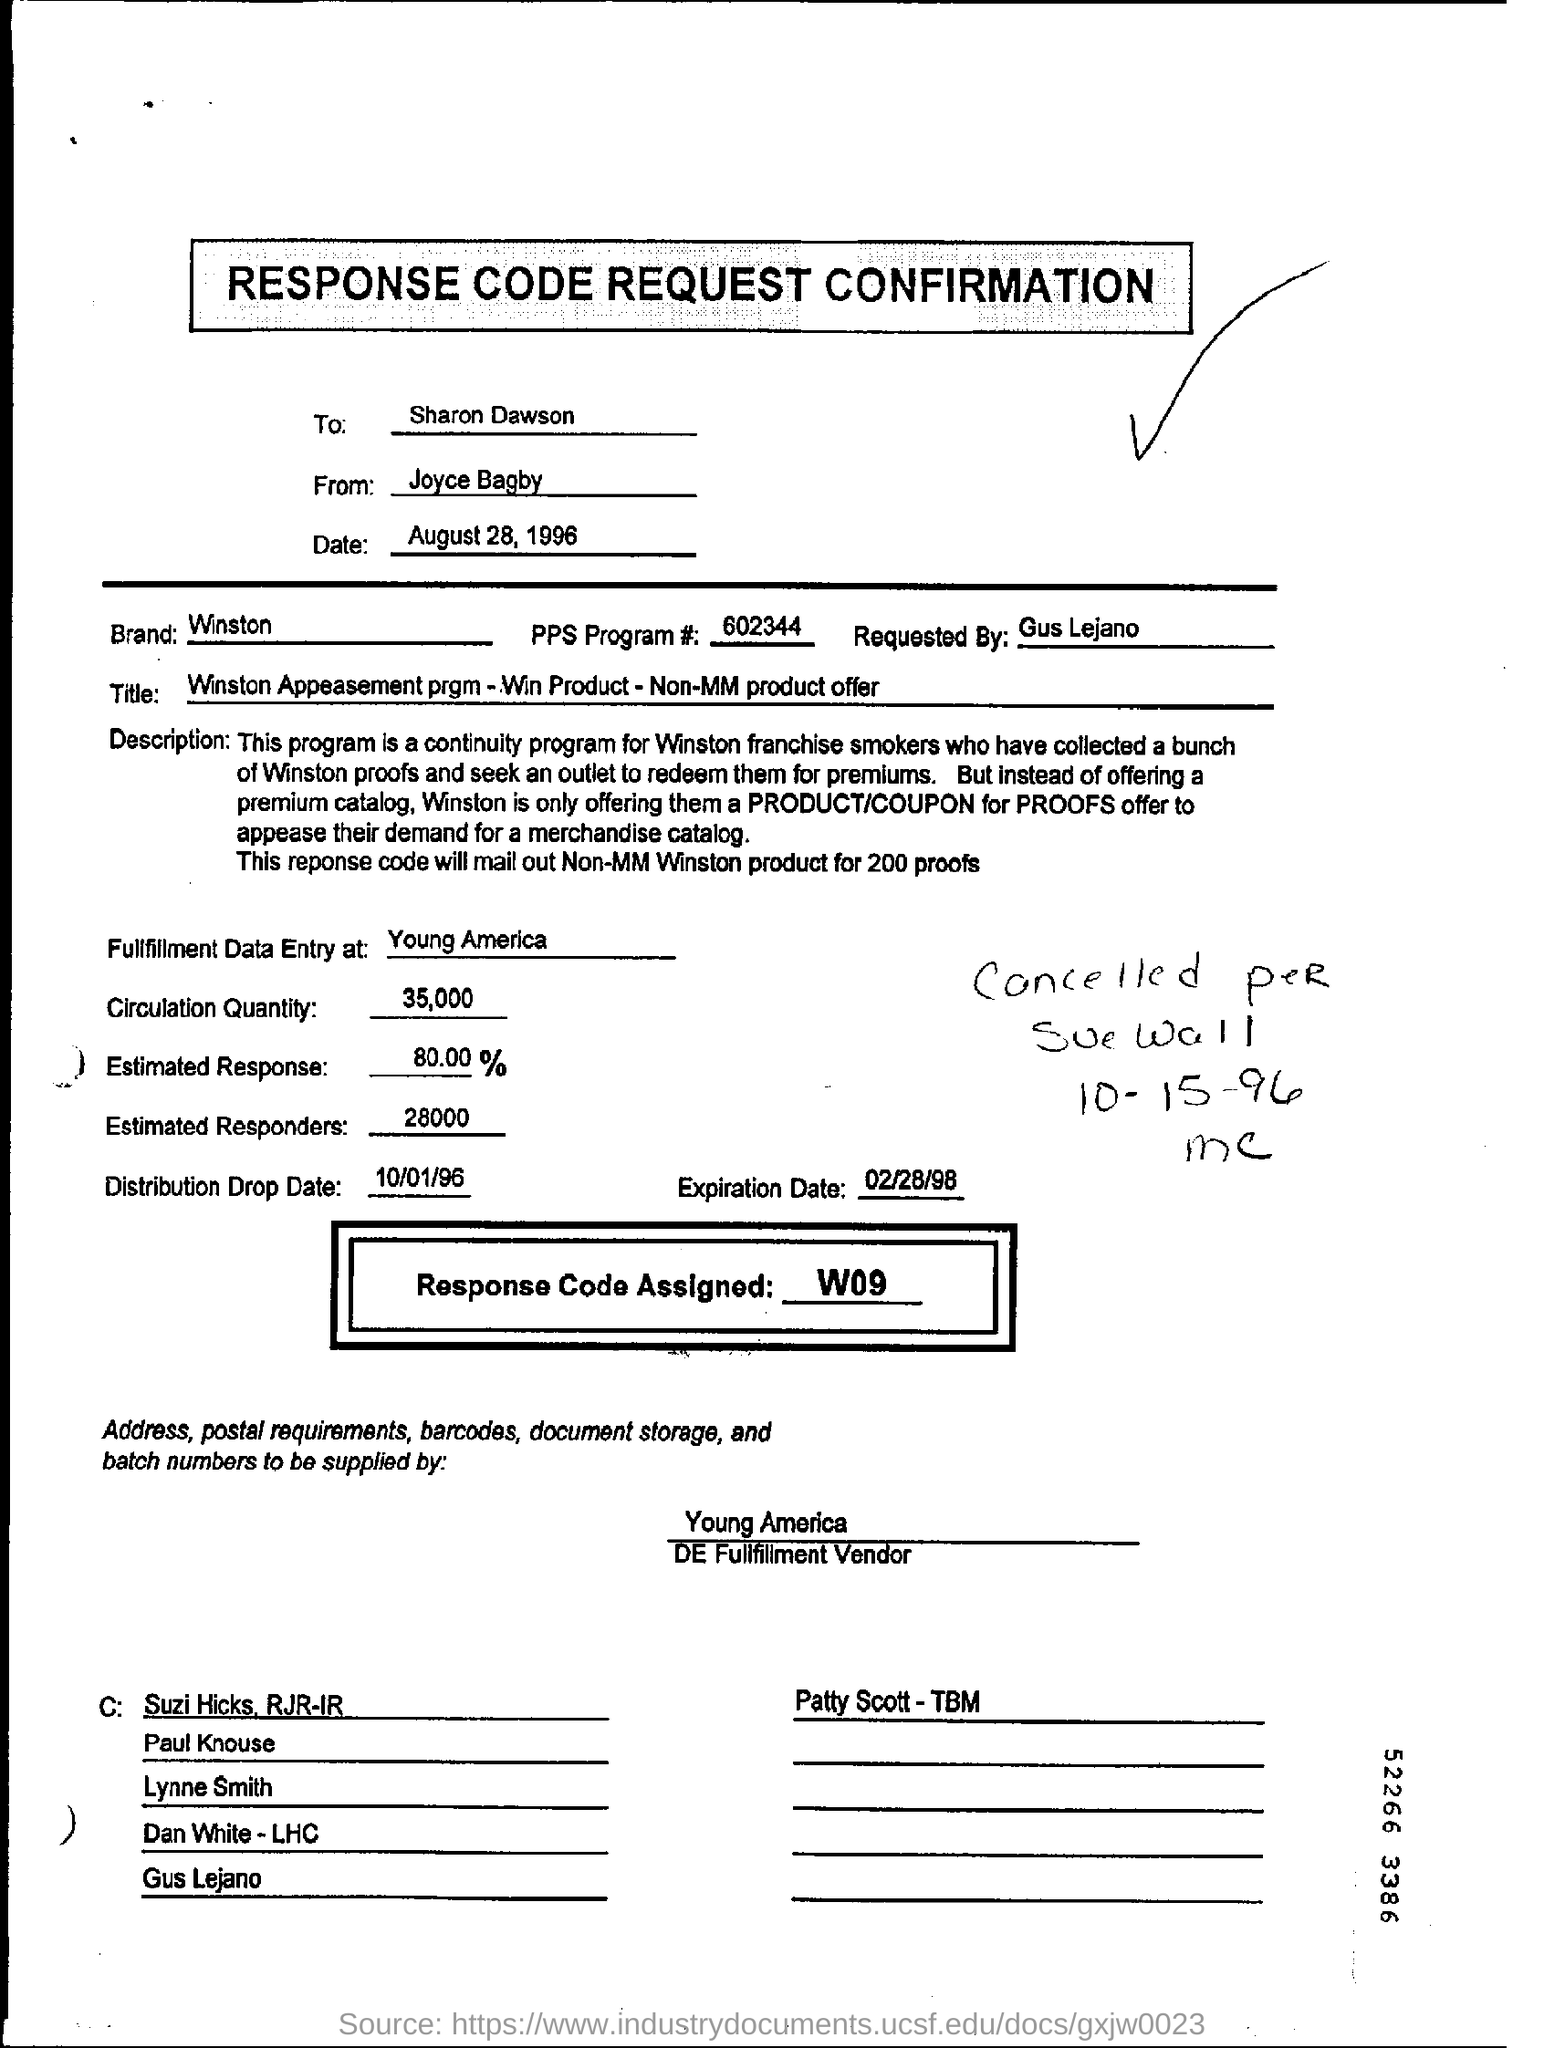Mention to whom,response code request confirmation is send?
Keep it short and to the point. Sharon Dawson. Who send the response code request confirmation to Sharon Dawson?
Your answer should be compact. JOYCE BAGBY. Mention the date on which the  request is send?
Give a very brief answer. August 28,1996. What is the percentage of 'estimated response' ?
Provide a short and direct response. 80.00%. What is the reponse code assigned for this confirmation request?
Make the answer very short. W09. What is entered in "Title" field in this form?
Offer a very short reply. Winston Appeasement prgm - Win Product - Non-MM product offer. 